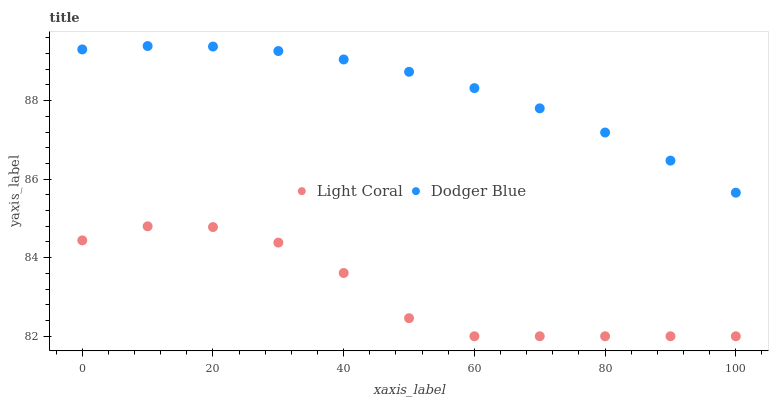Does Light Coral have the minimum area under the curve?
Answer yes or no. Yes. Does Dodger Blue have the maximum area under the curve?
Answer yes or no. Yes. Does Dodger Blue have the minimum area under the curve?
Answer yes or no. No. Is Dodger Blue the smoothest?
Answer yes or no. Yes. Is Light Coral the roughest?
Answer yes or no. Yes. Is Dodger Blue the roughest?
Answer yes or no. No. Does Light Coral have the lowest value?
Answer yes or no. Yes. Does Dodger Blue have the lowest value?
Answer yes or no. No. Does Dodger Blue have the highest value?
Answer yes or no. Yes. Is Light Coral less than Dodger Blue?
Answer yes or no. Yes. Is Dodger Blue greater than Light Coral?
Answer yes or no. Yes. Does Light Coral intersect Dodger Blue?
Answer yes or no. No. 